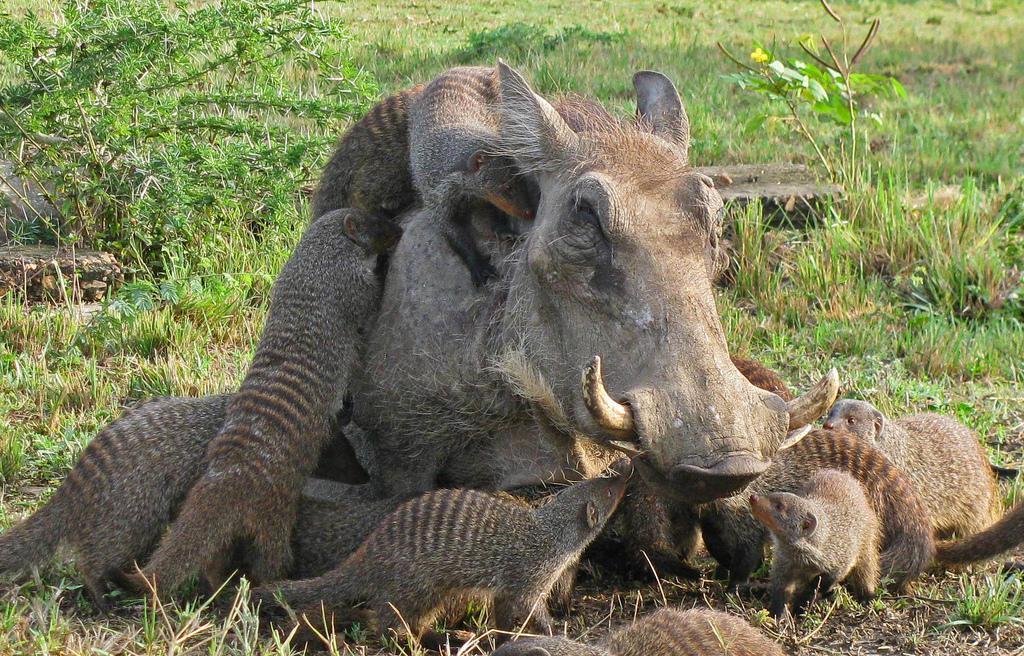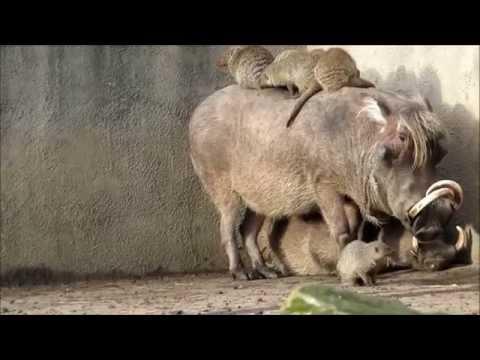The first image is the image on the left, the second image is the image on the right. Analyze the images presented: Is the assertion "the right pic has three or less animals" valid? Answer yes or no. No. 